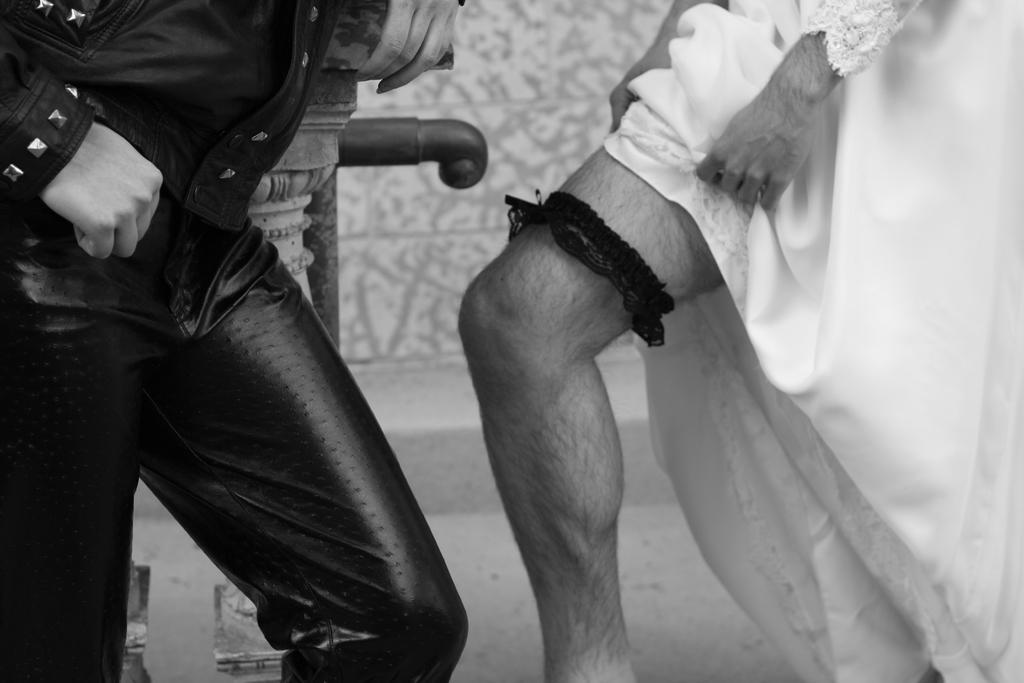Describe this image in one or two sentences. In this image we can see the legs of two persons. Here we can see a person on the left side is wearing a black color jacket and a pant. 